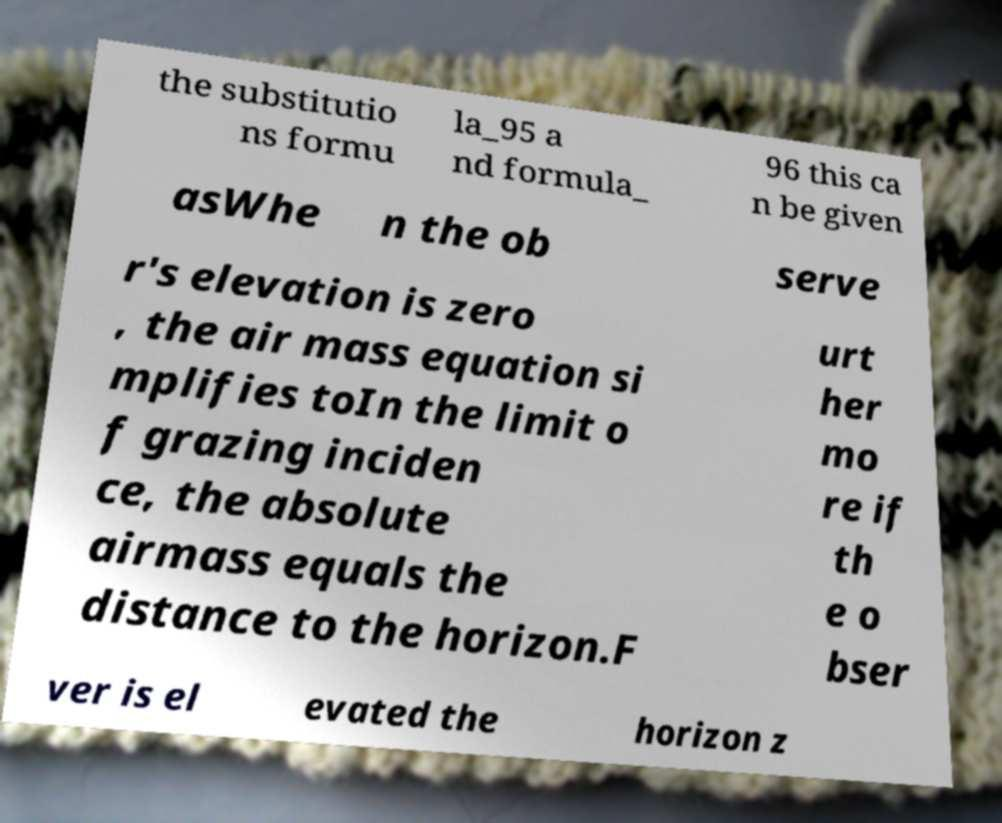Please read and relay the text visible in this image. What does it say? the substitutio ns formu la_95 a nd formula_ 96 this ca n be given asWhe n the ob serve r's elevation is zero , the air mass equation si mplifies toIn the limit o f grazing inciden ce, the absolute airmass equals the distance to the horizon.F urt her mo re if th e o bser ver is el evated the horizon z 